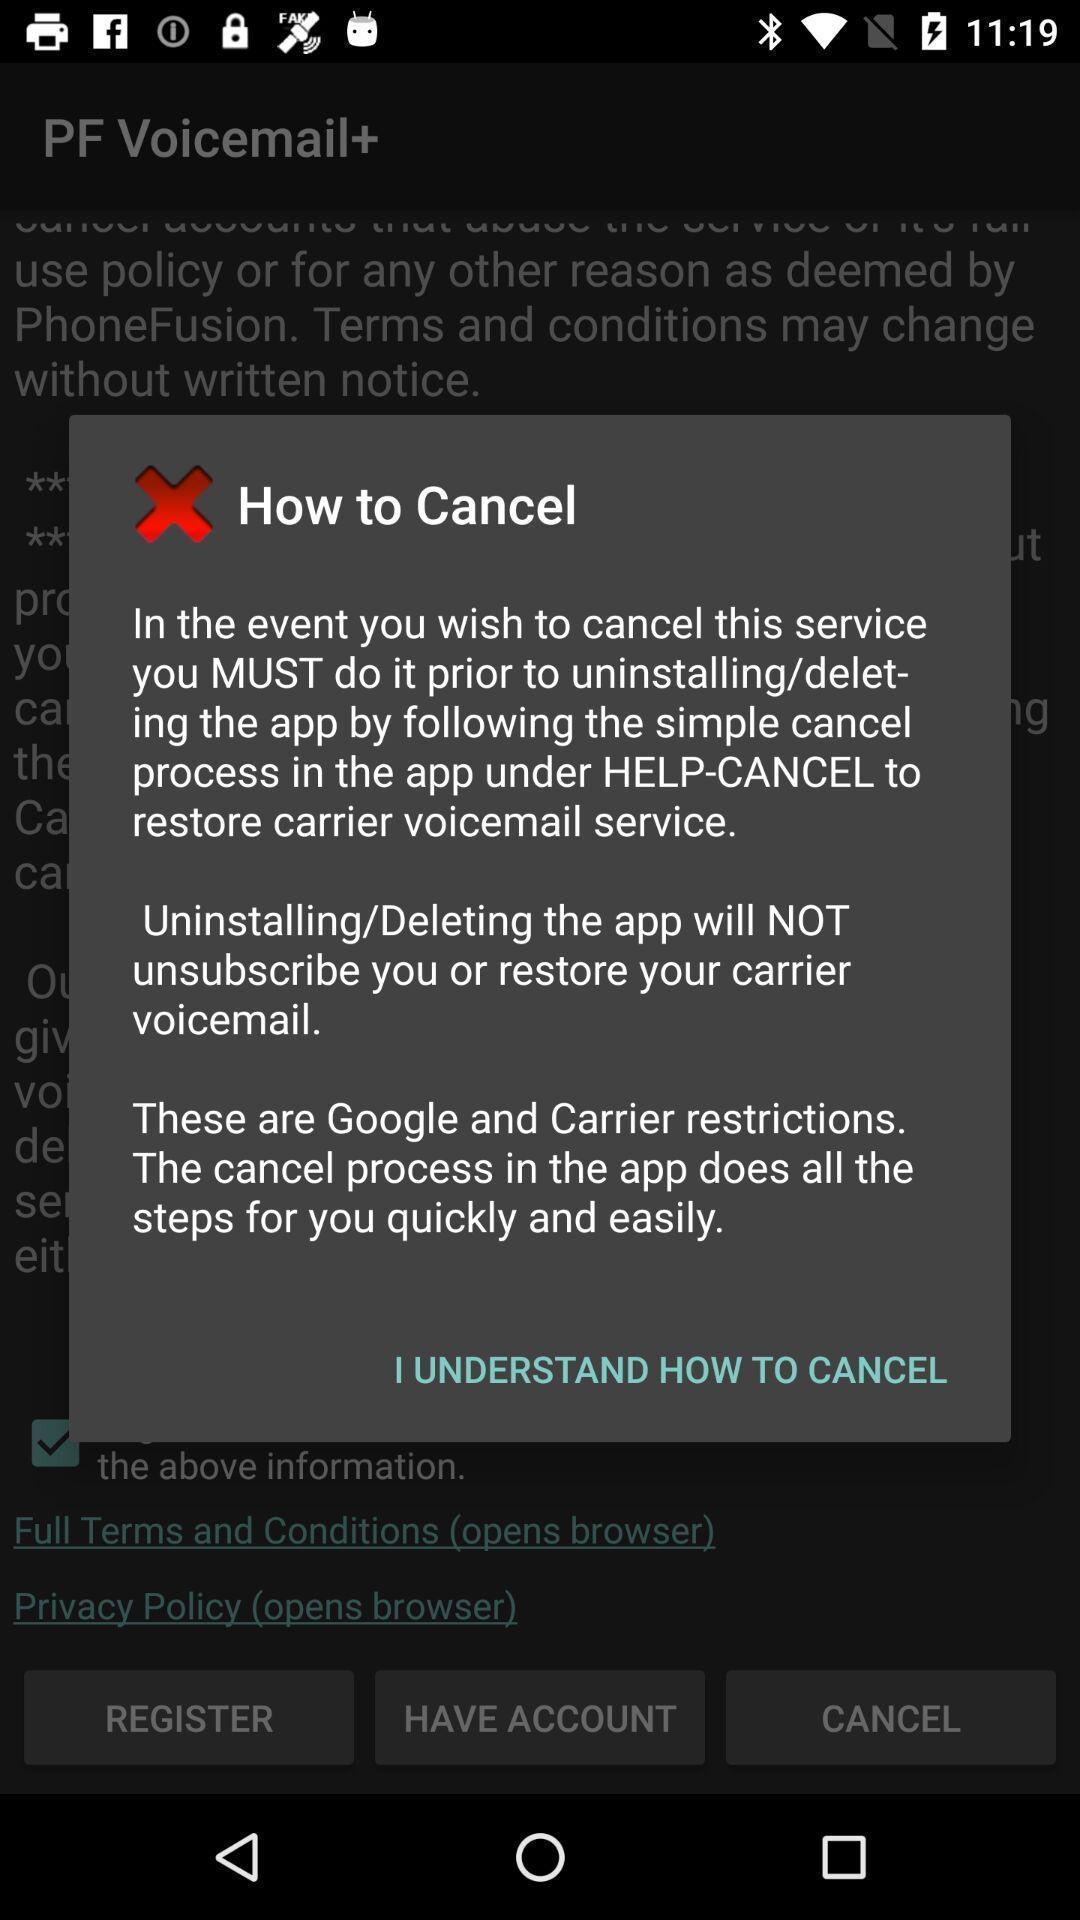What details can you identify in this image? Pop-up window showing message about usage of a feature. 